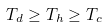<formula> <loc_0><loc_0><loc_500><loc_500>T _ { d } \geq T _ { h } \geq T _ { c }</formula> 